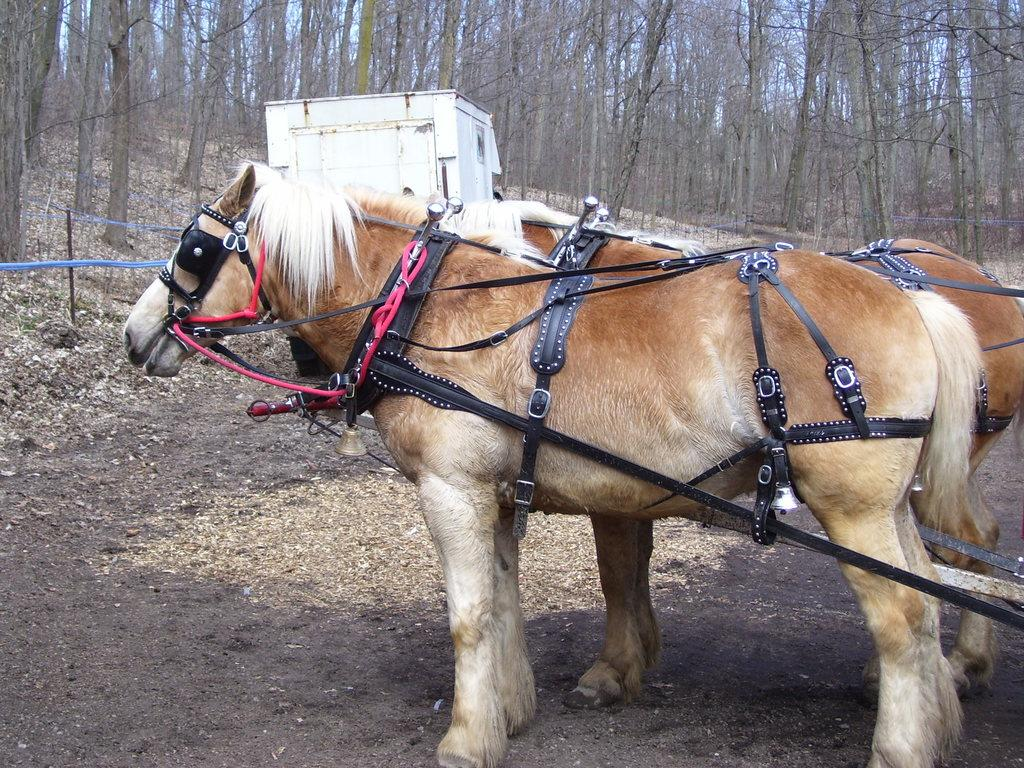What types of living organisms can be seen in the image? There are animals in the image. What can be seen beneath the animals in the image? The ground is visible in the image. What is present on the ground in the image? There are objects on the ground. What type of vegetation is visible in the image? There are trees in the image. What is visible above the animals and trees in the image? The sky is visible in the image. What structure can be seen in the image, aside from the trees and animals? There is a pole with some cloth in the image. How many crows are sitting on the birth of the north in the image? There are no crows, birth, or north mentioned in the image. The image features animals, ground, objects, trees, sky, and a pole with cloth. 